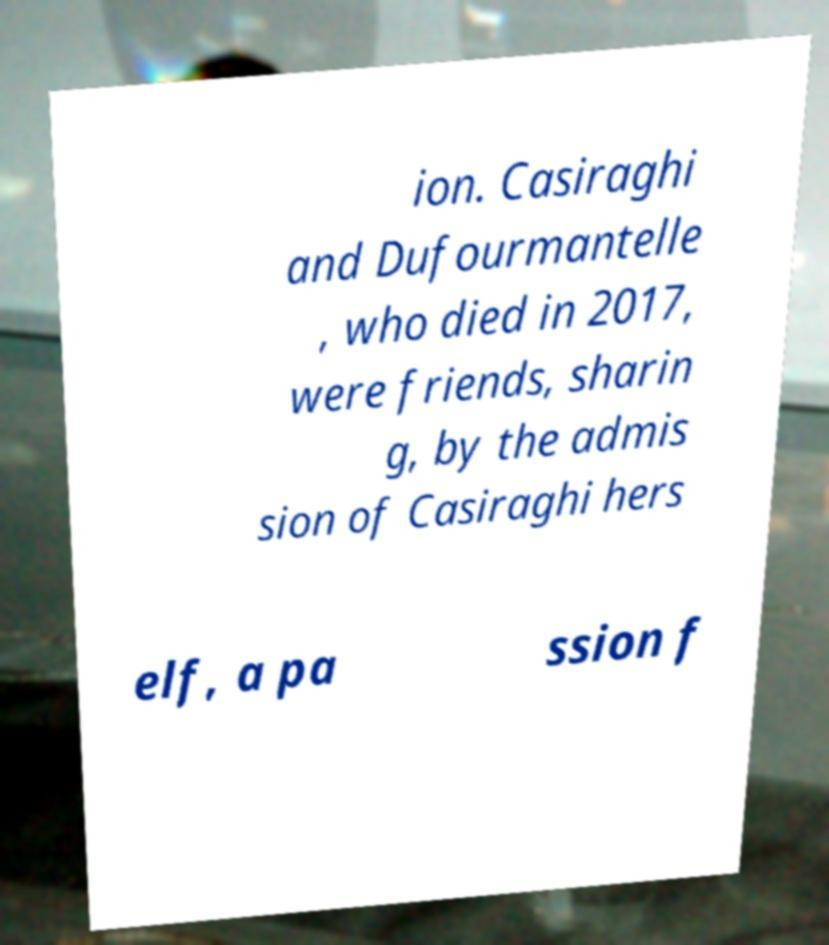Please read and relay the text visible in this image. What does it say? ion. Casiraghi and Dufourmantelle , who died in 2017, were friends, sharin g, by the admis sion of Casiraghi hers elf, a pa ssion f 